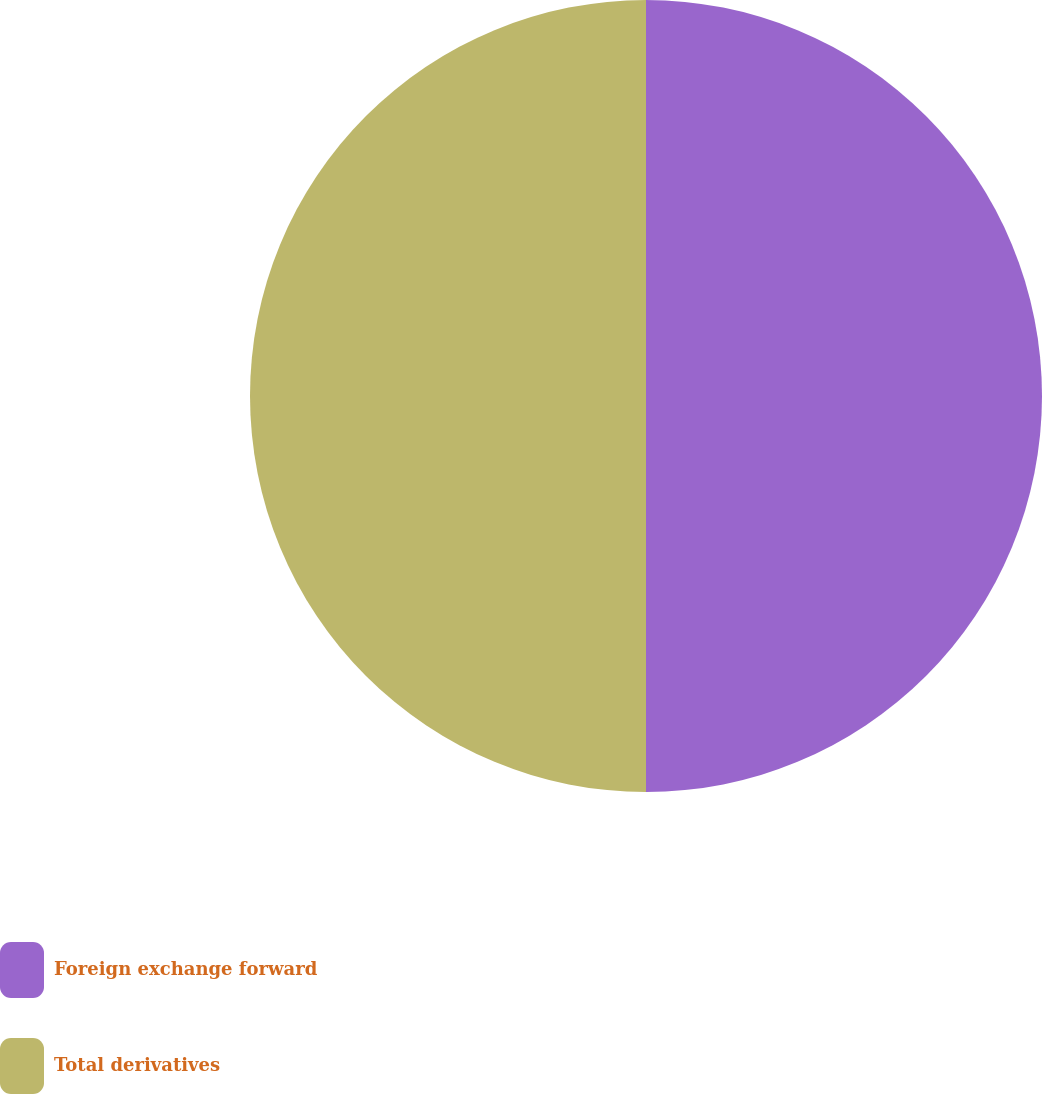Convert chart. <chart><loc_0><loc_0><loc_500><loc_500><pie_chart><fcel>Foreign exchange forward<fcel>Total derivatives<nl><fcel>50.0%<fcel>50.0%<nl></chart> 